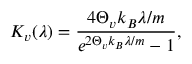Convert formula to latex. <formula><loc_0><loc_0><loc_500><loc_500>K _ { v } ( \lambda ) = \frac { 4 \Theta _ { v } k _ { B } \lambda / m } { e ^ { 2 \Theta _ { v } k _ { B } \lambda / m } - 1 } ,</formula> 